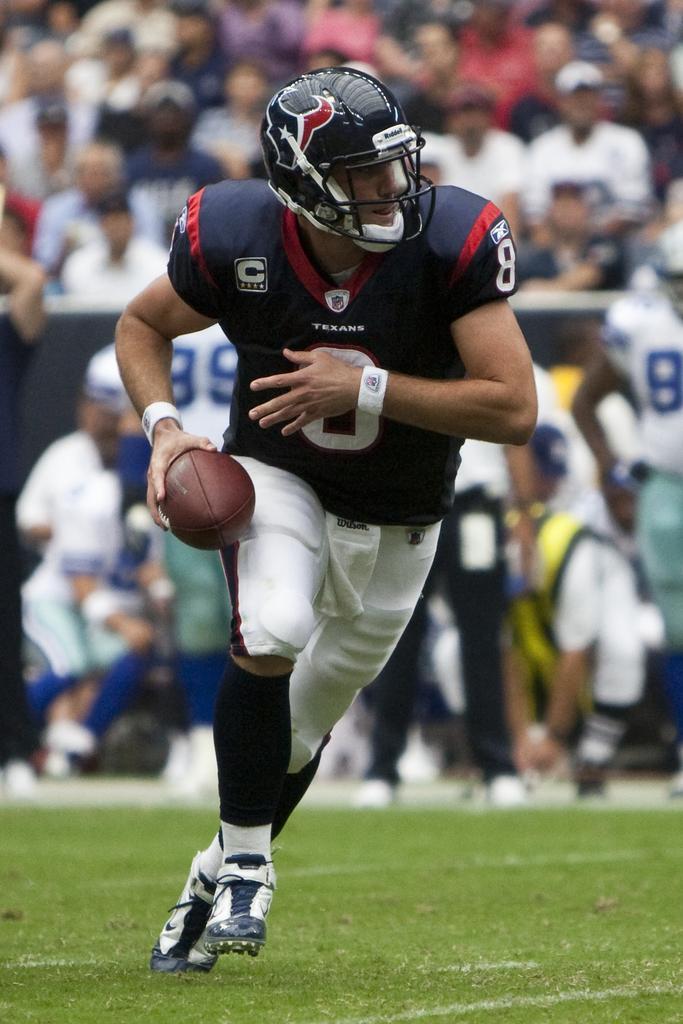Describe this image in one or two sentences. This picture is taken in the ground, In the middle there is a man holding a ball which is in brown color, In the background there are some people sitting and watching the match. 